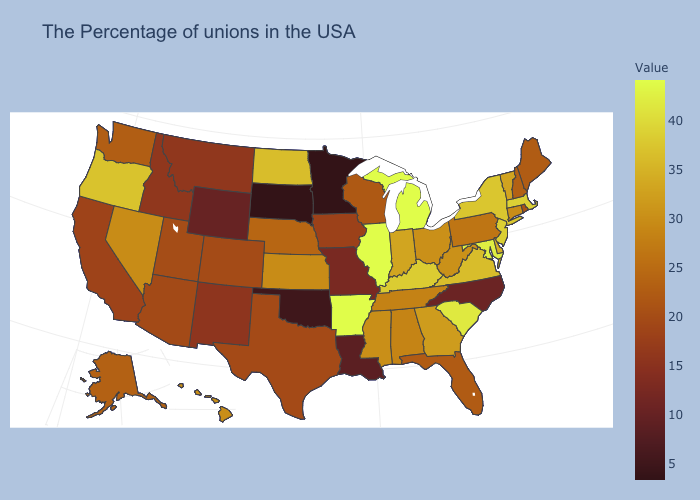Which states have the highest value in the USA?
Keep it brief. Michigan, Illinois, Arkansas. Among the states that border Maryland , which have the highest value?
Concise answer only. Virginia. Which states have the lowest value in the USA?
Write a very short answer. Minnesota, South Dakota. 